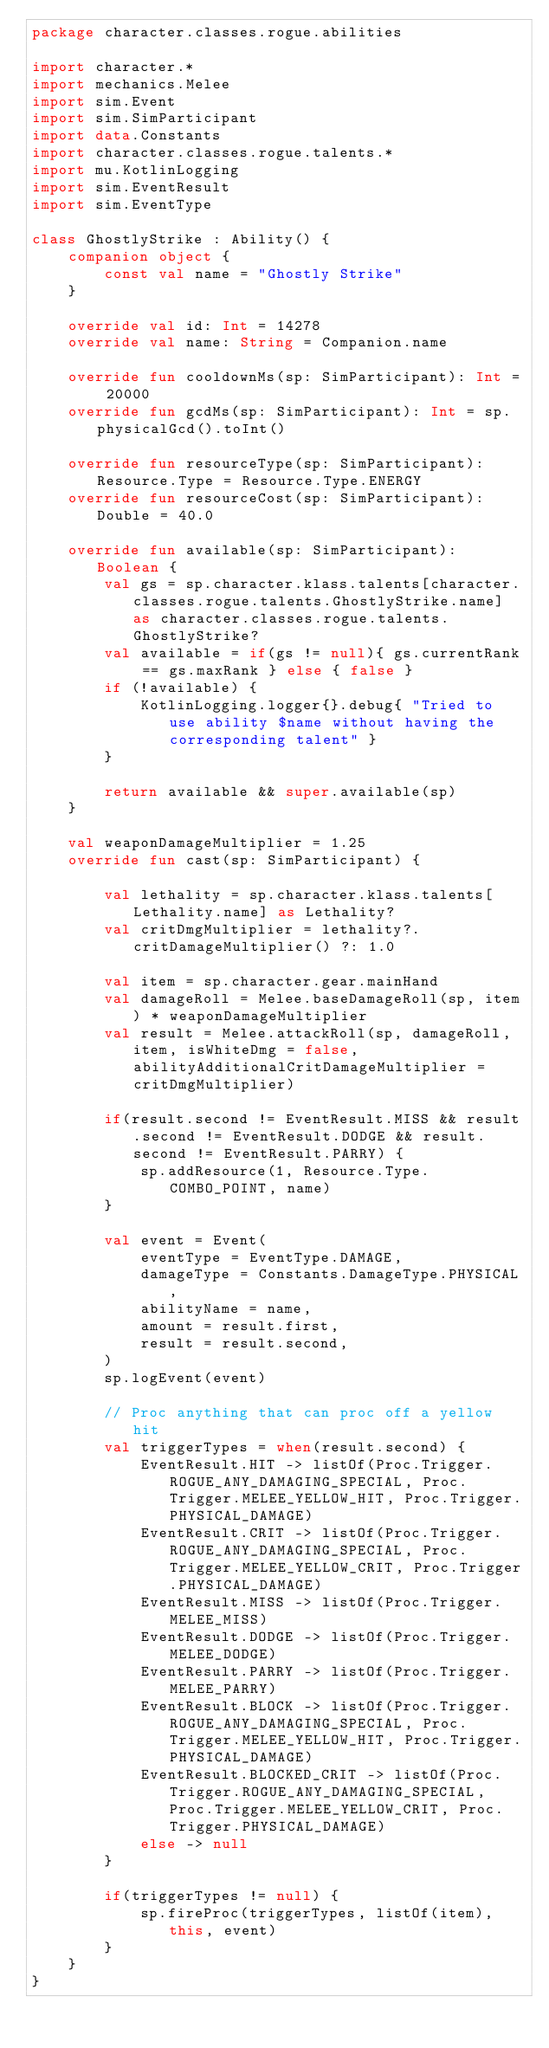Convert code to text. <code><loc_0><loc_0><loc_500><loc_500><_Kotlin_>package character.classes.rogue.abilities

import character.*
import mechanics.Melee
import sim.Event
import sim.SimParticipant
import data.Constants
import character.classes.rogue.talents.*
import mu.KotlinLogging
import sim.EventResult
import sim.EventType

class GhostlyStrike : Ability() {
    companion object {
        const val name = "Ghostly Strike"
    }

    override val id: Int = 14278
    override val name: String = Companion.name

    override fun cooldownMs(sp: SimParticipant): Int = 20000
    override fun gcdMs(sp: SimParticipant): Int = sp.physicalGcd().toInt()

    override fun resourceType(sp: SimParticipant): Resource.Type = Resource.Type.ENERGY
    override fun resourceCost(sp: SimParticipant): Double = 40.0

    override fun available(sp: SimParticipant): Boolean {
        val gs = sp.character.klass.talents[character.classes.rogue.talents.GhostlyStrike.name] as character.classes.rogue.talents.GhostlyStrike?
        val available = if(gs != null){ gs.currentRank == gs.maxRank } else { false }
        if (!available) {
            KotlinLogging.logger{}.debug{ "Tried to use ability $name without having the corresponding talent" }
        }

        return available && super.available(sp)
    }

    val weaponDamageMultiplier = 1.25
    override fun cast(sp: SimParticipant) {

        val lethality = sp.character.klass.talents[Lethality.name] as Lethality?
        val critDmgMultiplier = lethality?.critDamageMultiplier() ?: 1.0

        val item = sp.character.gear.mainHand
        val damageRoll = Melee.baseDamageRoll(sp, item) * weaponDamageMultiplier
        val result = Melee.attackRoll(sp, damageRoll, item, isWhiteDmg = false, abilityAdditionalCritDamageMultiplier = critDmgMultiplier)

        if(result.second != EventResult.MISS && result.second != EventResult.DODGE && result.second != EventResult.PARRY) {
            sp.addResource(1, Resource.Type.COMBO_POINT, name)
        }

        val event = Event(
            eventType = EventType.DAMAGE,
            damageType = Constants.DamageType.PHYSICAL,
            abilityName = name,
            amount = result.first,
            result = result.second,
        )
        sp.logEvent(event)

        // Proc anything that can proc off a yellow hit
        val triggerTypes = when(result.second) {
            EventResult.HIT -> listOf(Proc.Trigger.ROGUE_ANY_DAMAGING_SPECIAL, Proc.Trigger.MELEE_YELLOW_HIT, Proc.Trigger.PHYSICAL_DAMAGE)
            EventResult.CRIT -> listOf(Proc.Trigger.ROGUE_ANY_DAMAGING_SPECIAL, Proc.Trigger.MELEE_YELLOW_CRIT, Proc.Trigger.PHYSICAL_DAMAGE)
            EventResult.MISS -> listOf(Proc.Trigger.MELEE_MISS)
            EventResult.DODGE -> listOf(Proc.Trigger.MELEE_DODGE)
            EventResult.PARRY -> listOf(Proc.Trigger.MELEE_PARRY)
            EventResult.BLOCK -> listOf(Proc.Trigger.ROGUE_ANY_DAMAGING_SPECIAL, Proc.Trigger.MELEE_YELLOW_HIT, Proc.Trigger.PHYSICAL_DAMAGE)
            EventResult.BLOCKED_CRIT -> listOf(Proc.Trigger.ROGUE_ANY_DAMAGING_SPECIAL, Proc.Trigger.MELEE_YELLOW_CRIT, Proc.Trigger.PHYSICAL_DAMAGE)
            else -> null
        }

        if(triggerTypes != null) {
            sp.fireProc(triggerTypes, listOf(item), this, event)
        }
    }
}
</code> 